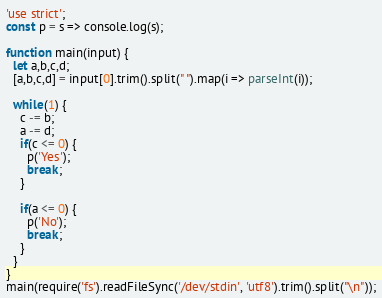<code> <loc_0><loc_0><loc_500><loc_500><_JavaScript_>'use strict';
const p = s => console.log(s);

function main(input) {
  let a,b,c,d;
  [a,b,c,d] = input[0].trim().split(" ").map(i => parseInt(i));

  while(1) {
    c -= b;
    a -= d;
    if(c <= 0) {
      p('Yes');
      break;
    }

    if(a <= 0) {
      p('No');
      break;
    }
  }
}
main(require('fs').readFileSync('/dev/stdin', 'utf8').trim().split("\n"));
</code> 